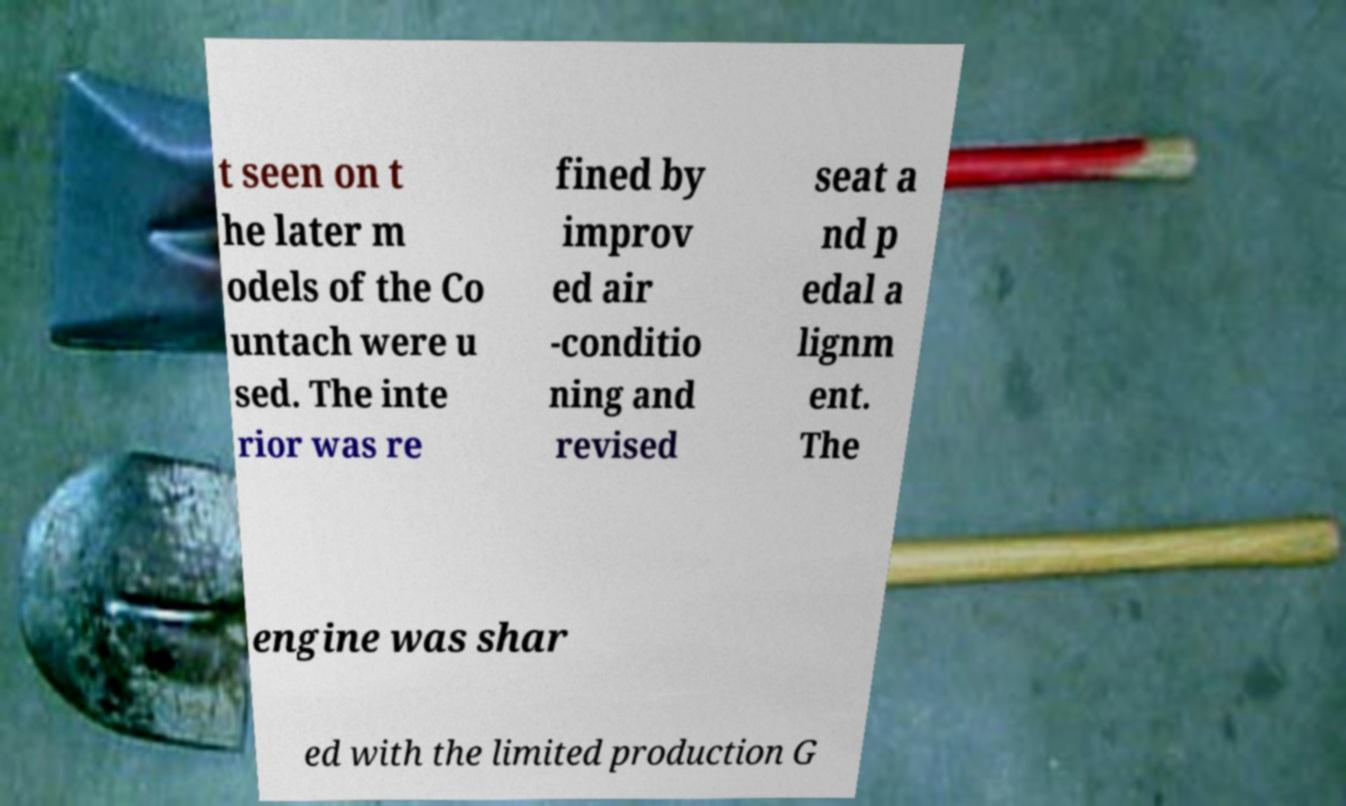Could you extract and type out the text from this image? t seen on t he later m odels of the Co untach were u sed. The inte rior was re fined by improv ed air -conditio ning and revised seat a nd p edal a lignm ent. The engine was shar ed with the limited production G 